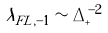<formula> <loc_0><loc_0><loc_500><loc_500>\lambda _ { F L , - 1 } \sim \Delta _ { + } ^ { - 2 }</formula> 